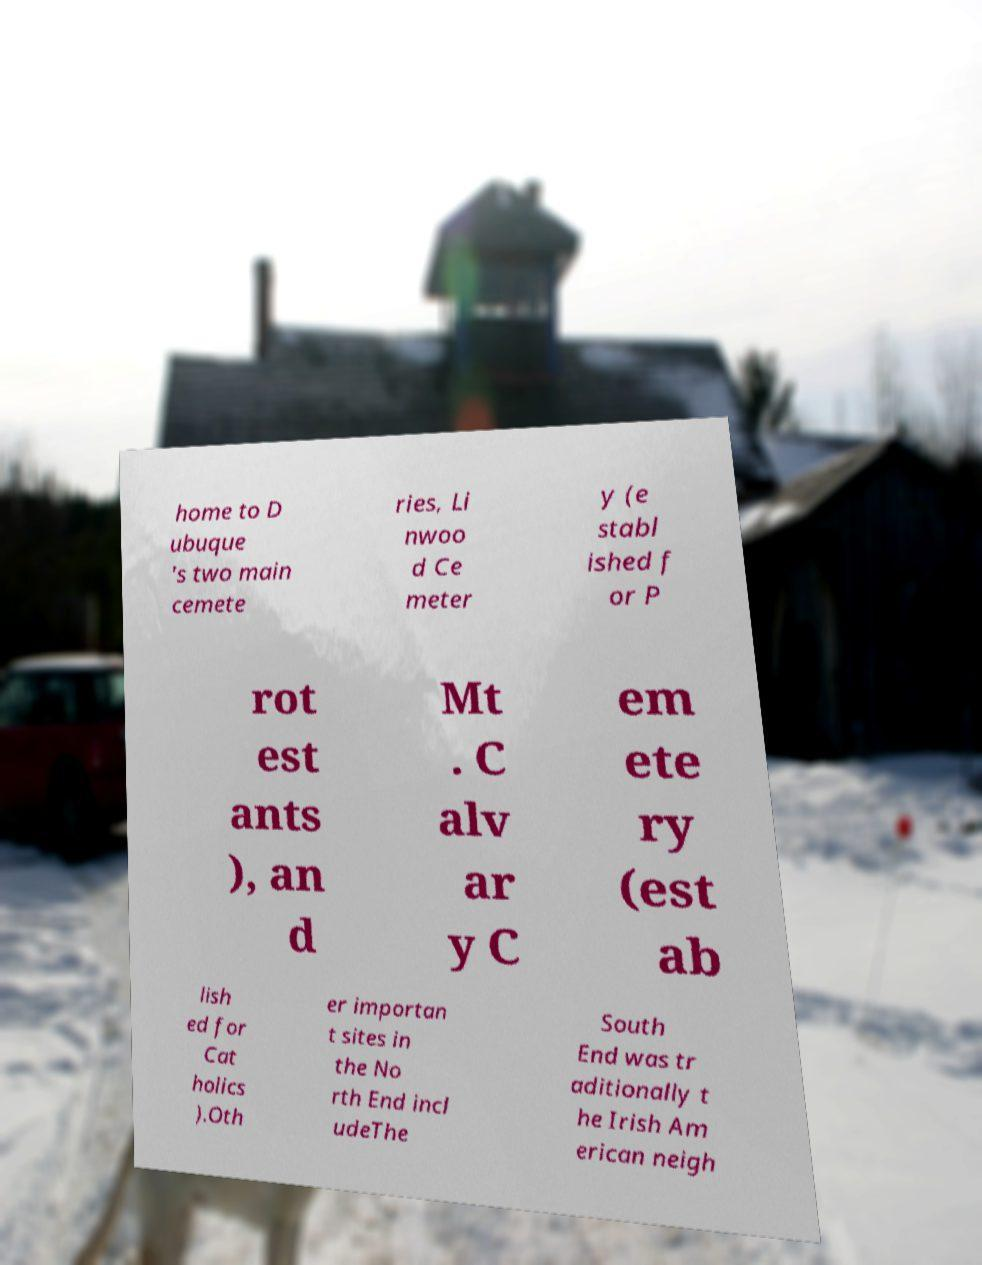Could you assist in decoding the text presented in this image and type it out clearly? home to D ubuque 's two main cemete ries, Li nwoo d Ce meter y (e stabl ished f or P rot est ants ), an d Mt . C alv ar y C em ete ry (est ab lish ed for Cat holics ).Oth er importan t sites in the No rth End incl udeThe South End was tr aditionally t he Irish Am erican neigh 